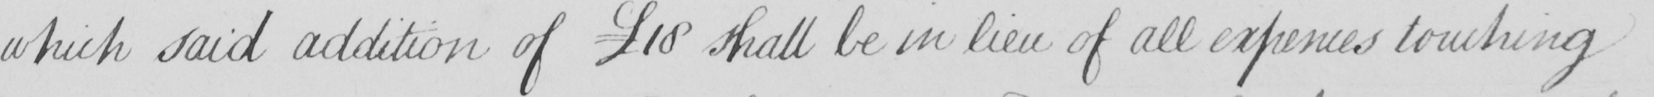What does this handwritten line say? which said addition of  £18 shall be in lieu of all expenses touching 